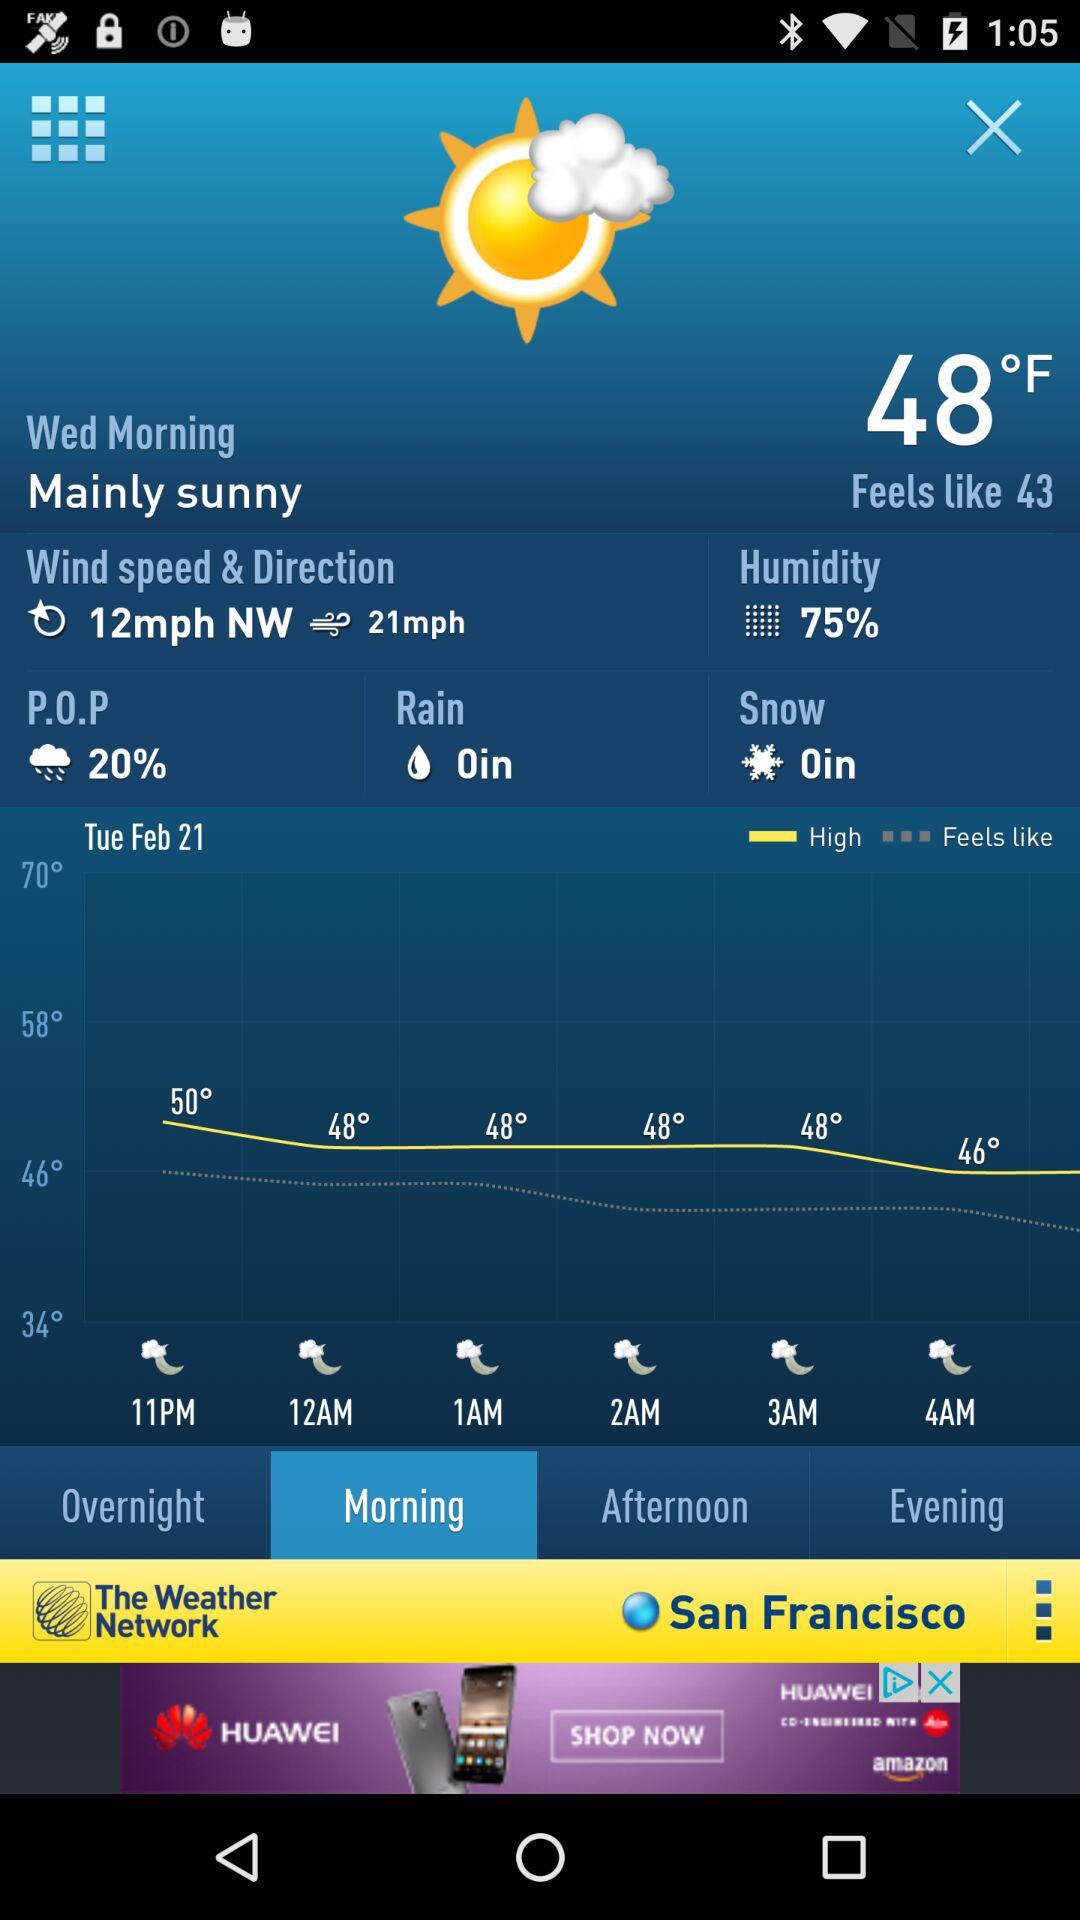What is the probability of precipitation in percentage? The probability of precipitation in percentage is 20. 